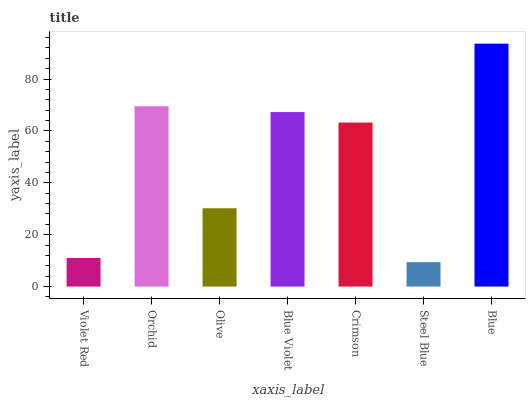Is Steel Blue the minimum?
Answer yes or no. Yes. Is Blue the maximum?
Answer yes or no. Yes. Is Orchid the minimum?
Answer yes or no. No. Is Orchid the maximum?
Answer yes or no. No. Is Orchid greater than Violet Red?
Answer yes or no. Yes. Is Violet Red less than Orchid?
Answer yes or no. Yes. Is Violet Red greater than Orchid?
Answer yes or no. No. Is Orchid less than Violet Red?
Answer yes or no. No. Is Crimson the high median?
Answer yes or no. Yes. Is Crimson the low median?
Answer yes or no. Yes. Is Steel Blue the high median?
Answer yes or no. No. Is Violet Red the low median?
Answer yes or no. No. 